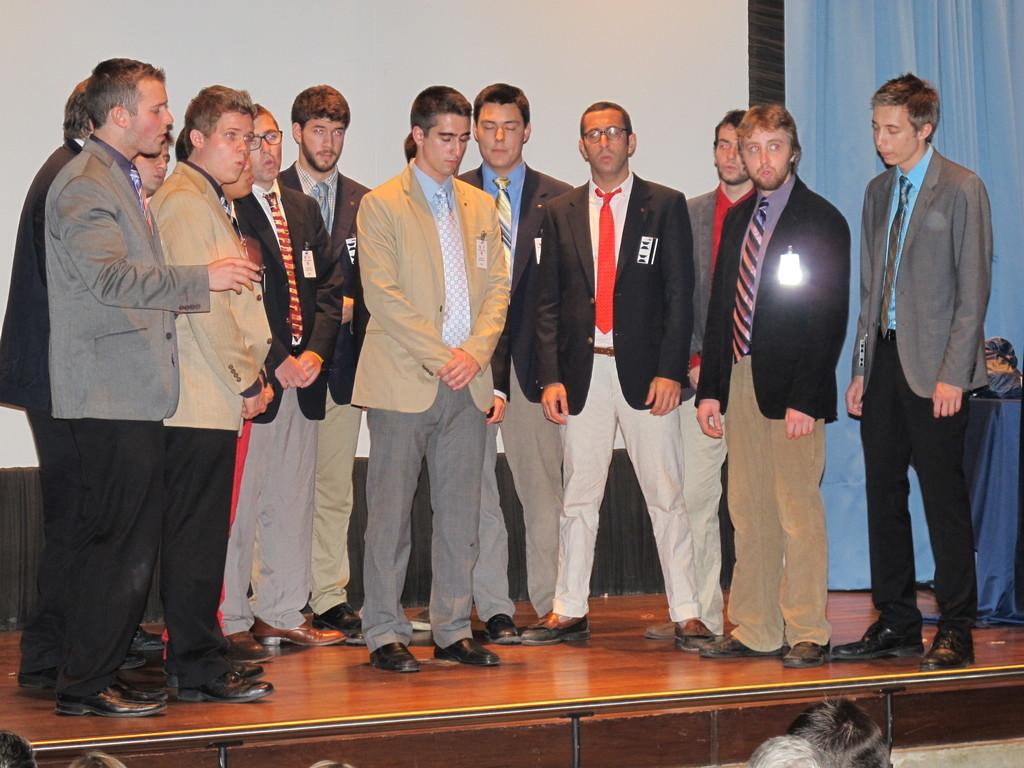What is happening in the center of the image? There are people standing in the center of the image. What can be seen in the background of the image? There is a wall and a curtain in the background of the image. Where is the table located in the image? The table is on the right side of the image. What type of breakfast is being served on the table in the image? There is no breakfast present in the image; the table is empty. How many legs can be seen on the people in the image? The question about the number of legs is irrelevant, as we cannot count the legs of people in the image. 